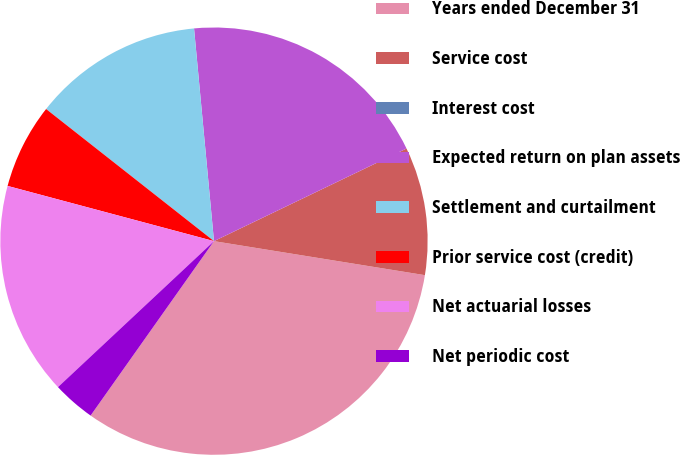Convert chart to OTSL. <chart><loc_0><loc_0><loc_500><loc_500><pie_chart><fcel>Years ended December 31<fcel>Service cost<fcel>Interest cost<fcel>Expected return on plan assets<fcel>Settlement and curtailment<fcel>Prior service cost (credit)<fcel>Net actuarial losses<fcel>Net periodic cost<nl><fcel>32.25%<fcel>9.68%<fcel>0.0%<fcel>19.35%<fcel>12.9%<fcel>6.45%<fcel>16.13%<fcel>3.23%<nl></chart> 